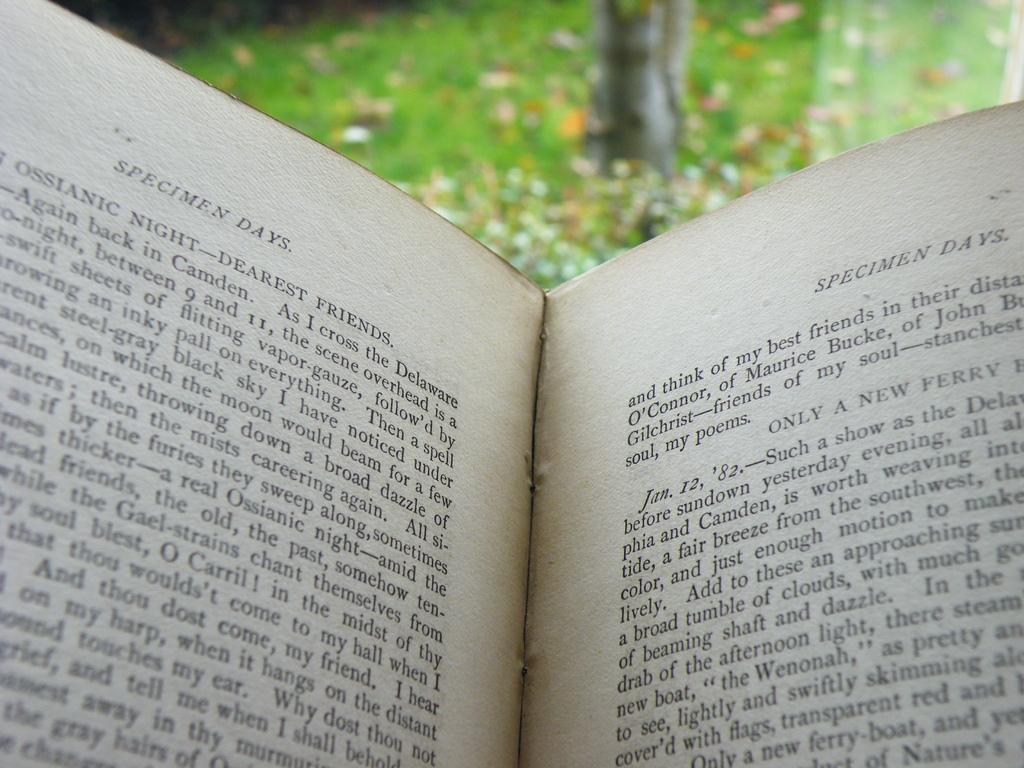<image>
Write a terse but informative summary of the picture. an open book named Specimen days being red out doors 